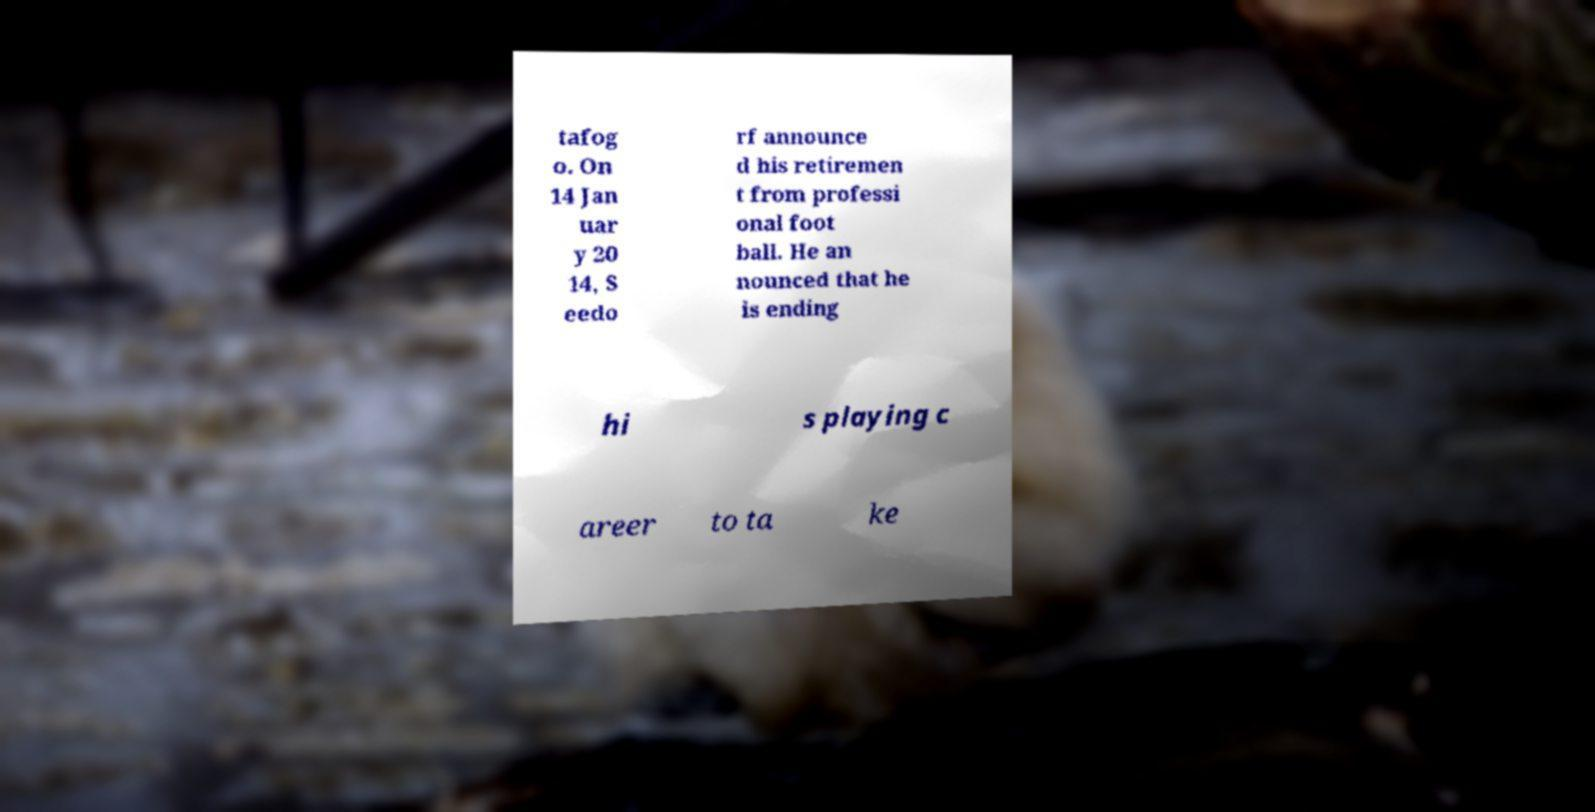For documentation purposes, I need the text within this image transcribed. Could you provide that? tafog o. On 14 Jan uar y 20 14, S eedo rf announce d his retiremen t from professi onal foot ball. He an nounced that he is ending hi s playing c areer to ta ke 